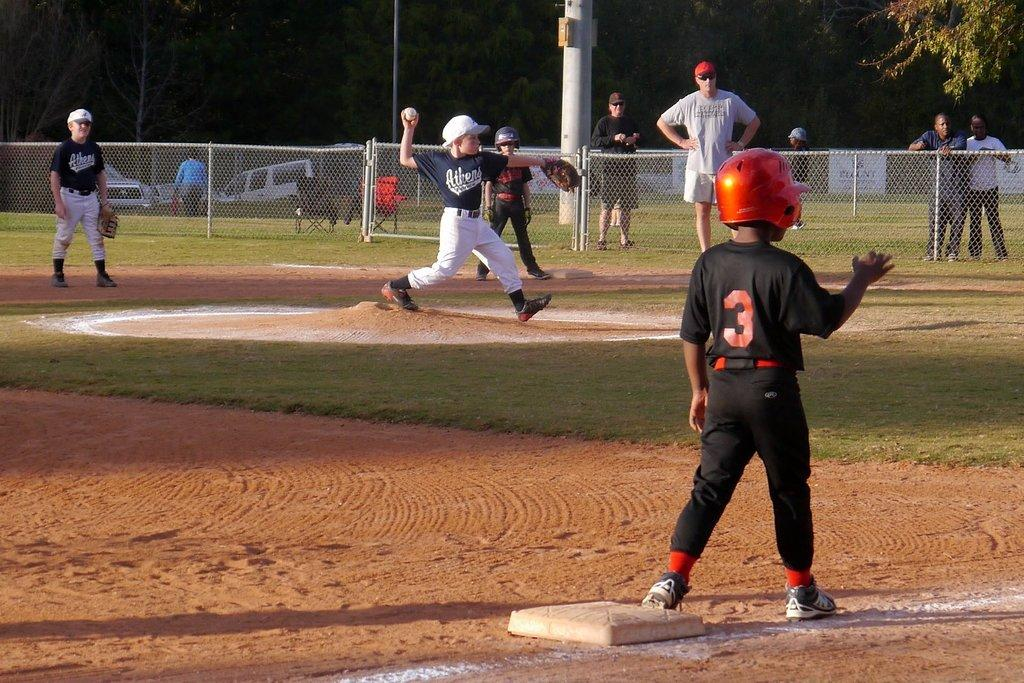Provide a one-sentence caption for the provided image. Baseball game between 2 teams with a base runner #3 on third base. 